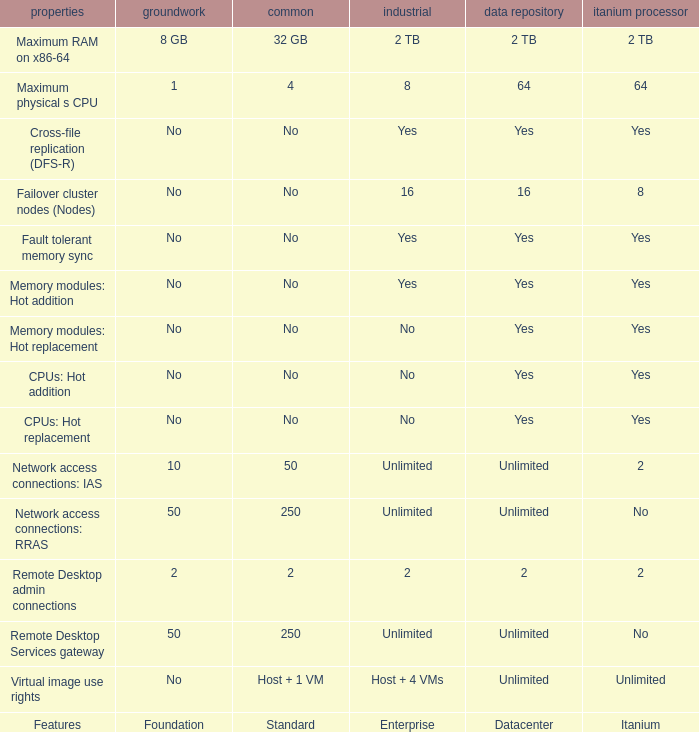What is the Datacenter for the Fault Tolerant Memory Sync Feature that has Yes for Itanium and No for Standard? Yes. 